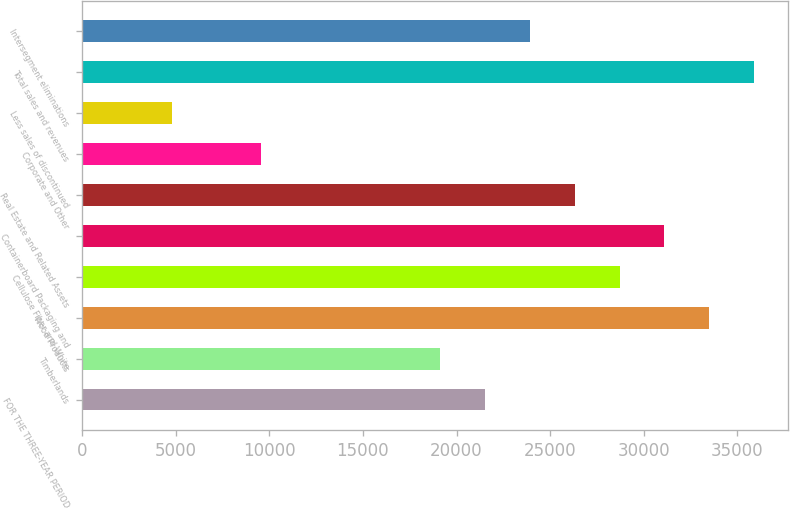<chart> <loc_0><loc_0><loc_500><loc_500><bar_chart><fcel>FOR THE THREE-YEAR PERIOD<fcel>Timberlands<fcel>Wood Products<fcel>Cellulose Fiber and White<fcel>Containerboard Packaging and<fcel>Real Estate and Related Assets<fcel>Corporate and Other<fcel>Less sales of discontinued<fcel>Total sales and revenues<fcel>Intersegment eliminations<nl><fcel>21535.4<fcel>19143.8<fcel>33493.4<fcel>28710.2<fcel>31101.8<fcel>26318.6<fcel>9577.4<fcel>4794.2<fcel>35885<fcel>23927<nl></chart> 